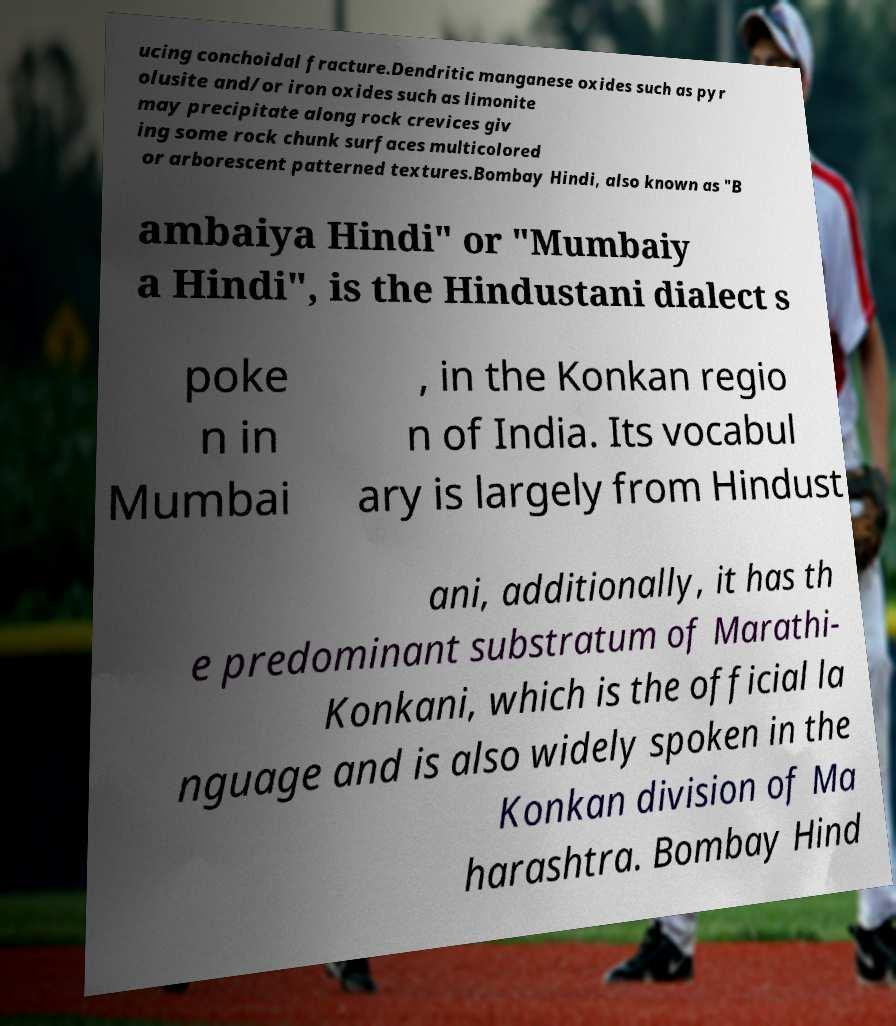There's text embedded in this image that I need extracted. Can you transcribe it verbatim? ucing conchoidal fracture.Dendritic manganese oxides such as pyr olusite and/or iron oxides such as limonite may precipitate along rock crevices giv ing some rock chunk surfaces multicolored or arborescent patterned textures.Bombay Hindi, also known as "B ambaiya Hindi" or "Mumbaiy a Hindi", is the Hindustani dialect s poke n in Mumbai , in the Konkan regio n of India. Its vocabul ary is largely from Hindust ani, additionally, it has th e predominant substratum of Marathi- Konkani, which is the official la nguage and is also widely spoken in the Konkan division of Ma harashtra. Bombay Hind 